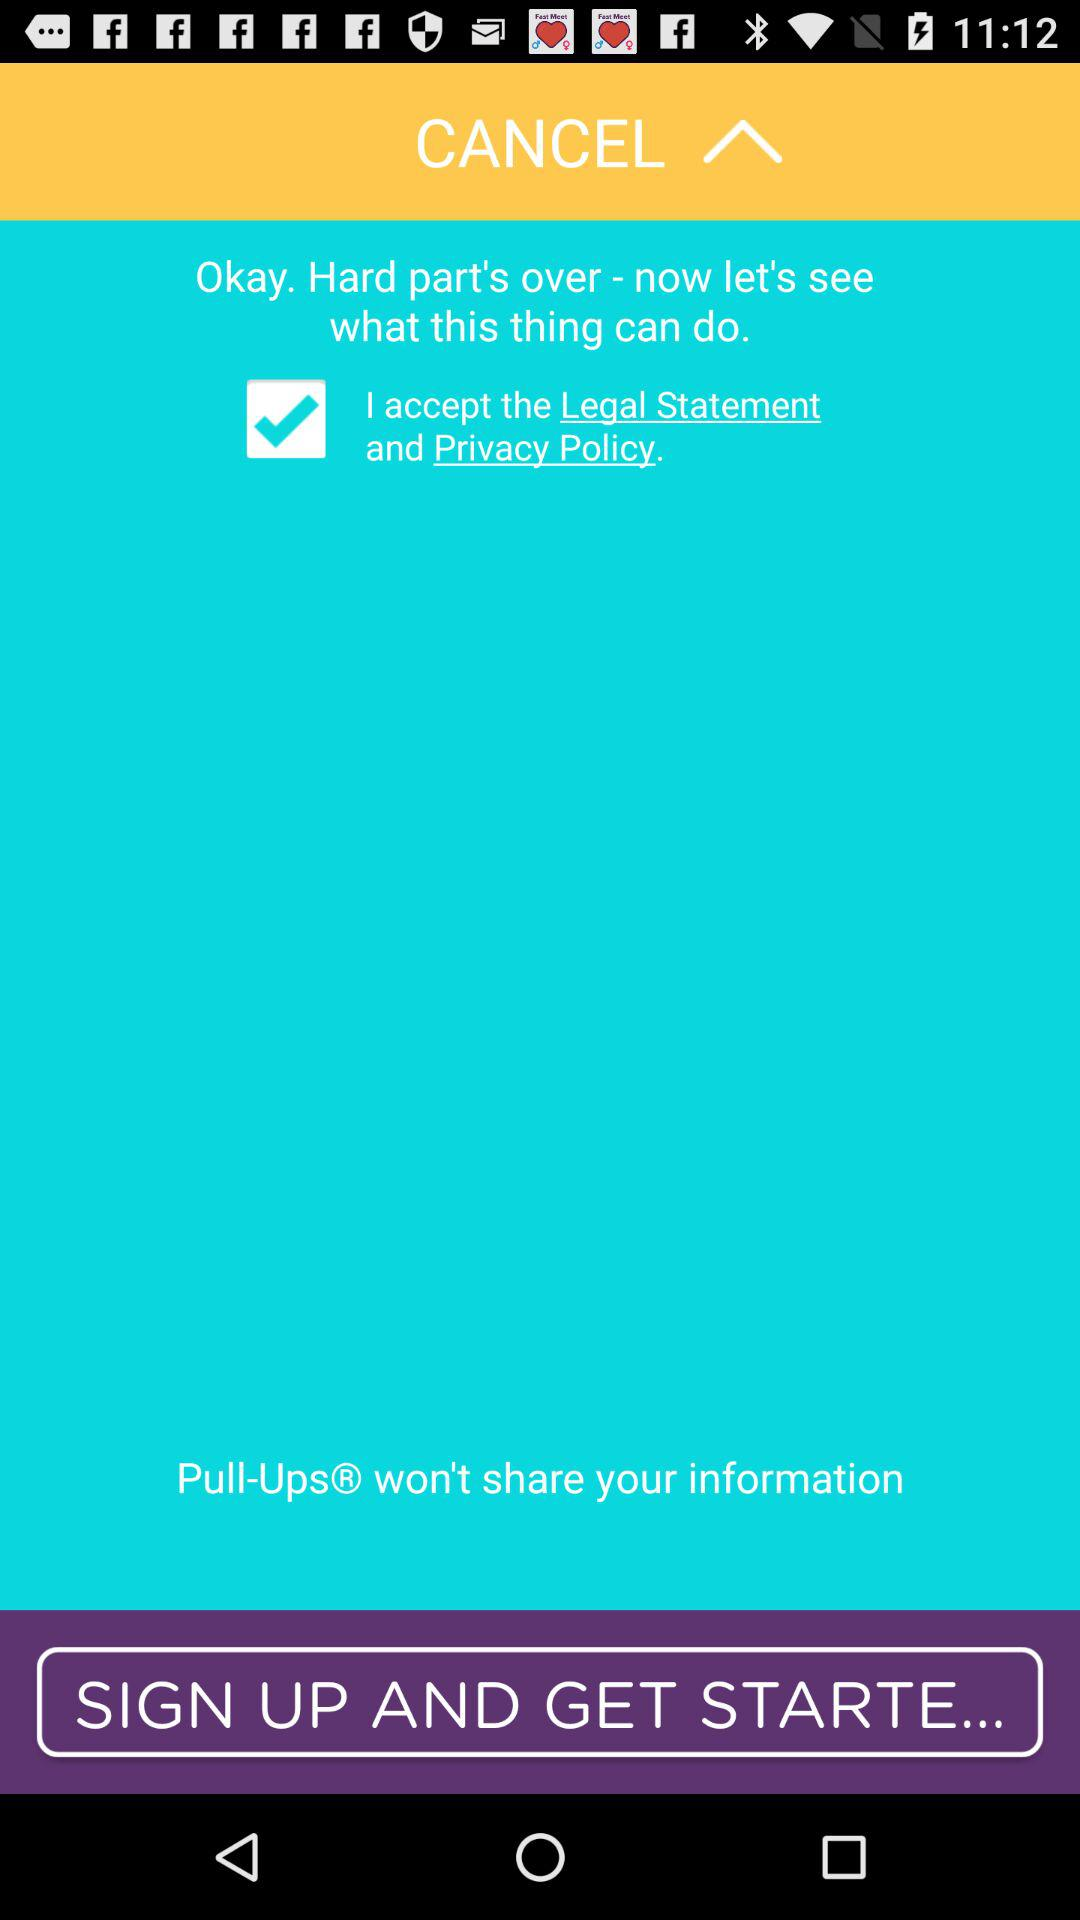What is the name of the application? The name of the application is "Pull-Ups". 